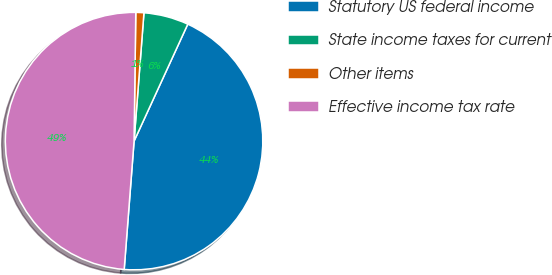Convert chart to OTSL. <chart><loc_0><loc_0><loc_500><loc_500><pie_chart><fcel>Statutory US federal income<fcel>State income taxes for current<fcel>Other items<fcel>Effective income tax rate<nl><fcel>44.37%<fcel>5.63%<fcel>1.01%<fcel>48.99%<nl></chart> 